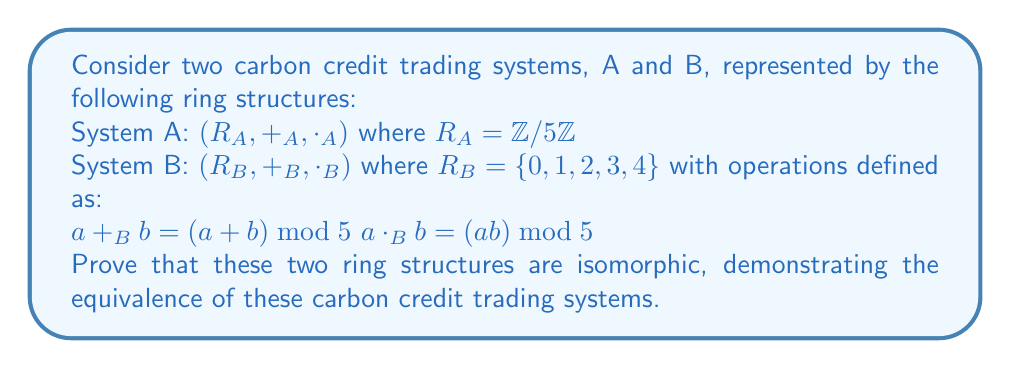Solve this math problem. To prove that the two ring structures are isomorphic, we need to find a bijective function $f: R_A \rightarrow R_B$ that preserves both addition and multiplication. We'll follow these steps:

1) Define the function $f$:
   Let $f: R_A \rightarrow R_B$ be defined as $f([x]_5) = x \bmod 5$ for $x \in \mathbb{Z}$.

2) Prove that $f$ is well-defined:
   If $[x]_5 = [y]_5$ in $R_A$, then $x \equiv y \pmod{5}$, so $x \bmod 5 = y \bmod 5$ in $R_B$.

3) Prove that $f$ is bijective:
   - Injective: If $f([x]_5) = f([y]_5)$, then $x \bmod 5 = y \bmod 5$, so $[x]_5 = [y]_5$ in $R_A$.
   - Surjective: For any $b \in R_B$, $f([b]_5) = b$.

4) Prove that $f$ preserves addition:
   $$f([x]_5 +_A [y]_5) = f([x+y]_5) = (x+y) \bmod 5 = (x \bmod 5) +_B (y \bmod 5) = f([x]_5) +_B f([y]_5)$$

5) Prove that $f$ preserves multiplication:
   $$f([x]_5 \cdot_A [y]_5) = f([xy]_5) = (xy) \bmod 5 = (x \bmod 5) \cdot_B (y \bmod 5) = f([x]_5) \cdot_B f([y]_5)$$

Since $f$ is a bijective homomorphism, it is an isomorphism between $R_A$ and $R_B$.
Answer: The ring structures $(R_A, +_A, \cdot_A)$ and $(R_B, +_B, \cdot_B)$ are isomorphic. The isomorphism is given by the function $f: R_A \rightarrow R_B$ defined as $f([x]_5) = x \bmod 5$ for $x \in \mathbb{Z}$. This isomorphism demonstrates that the two carbon credit trading systems are structurally equivalent. 